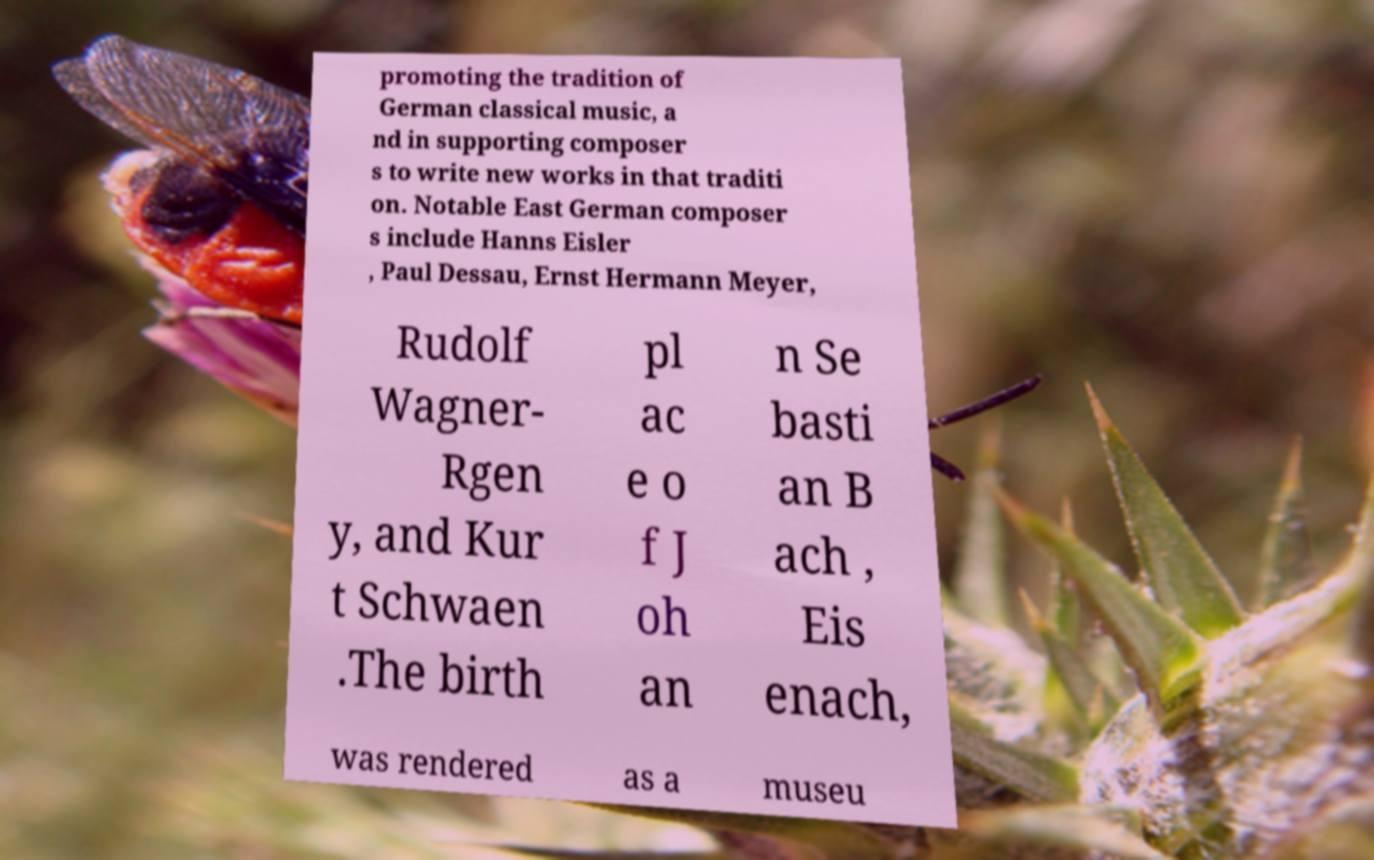For documentation purposes, I need the text within this image transcribed. Could you provide that? promoting the tradition of German classical music, a nd in supporting composer s to write new works in that traditi on. Notable East German composer s include Hanns Eisler , Paul Dessau, Ernst Hermann Meyer, Rudolf Wagner- Rgen y, and Kur t Schwaen .The birth pl ac e o f J oh an n Se basti an B ach , Eis enach, was rendered as a museu 